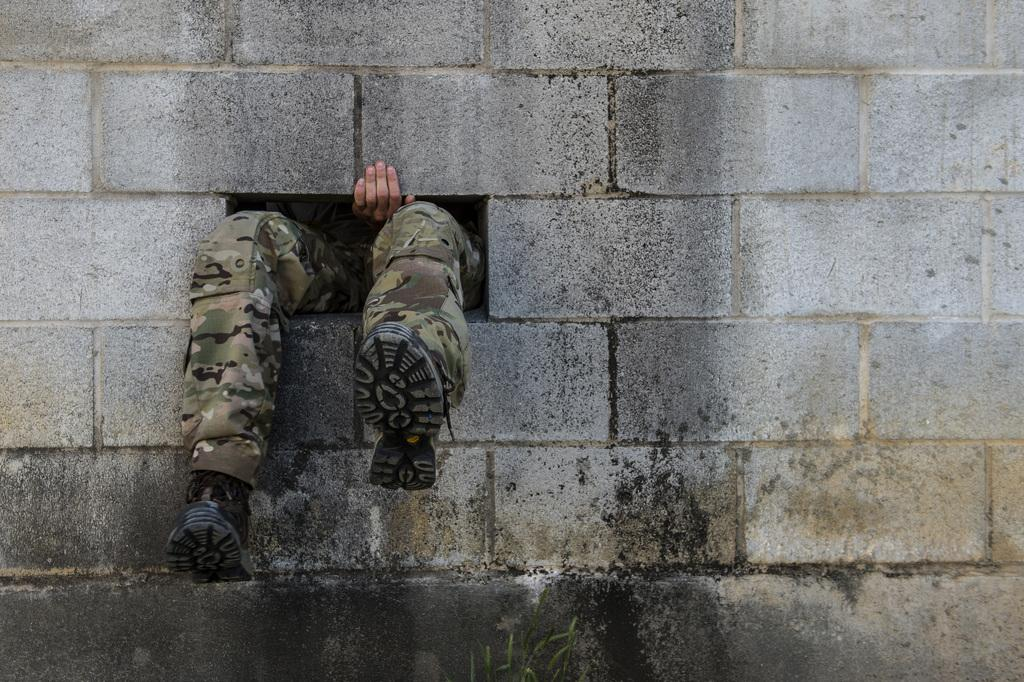What body parts of a person can be seen in the image? There are legs and a hand of a person in the image. What type of footwear is the person wearing? The person is wearing shoes. What material is the wall made of in the image? The wall in the image is made up of bricks. What type of rice is being cooked in the image? There is no rice present in the image. What sense is being stimulated by the image? The image does not stimulate any specific sense, as it is a static visual representation. 